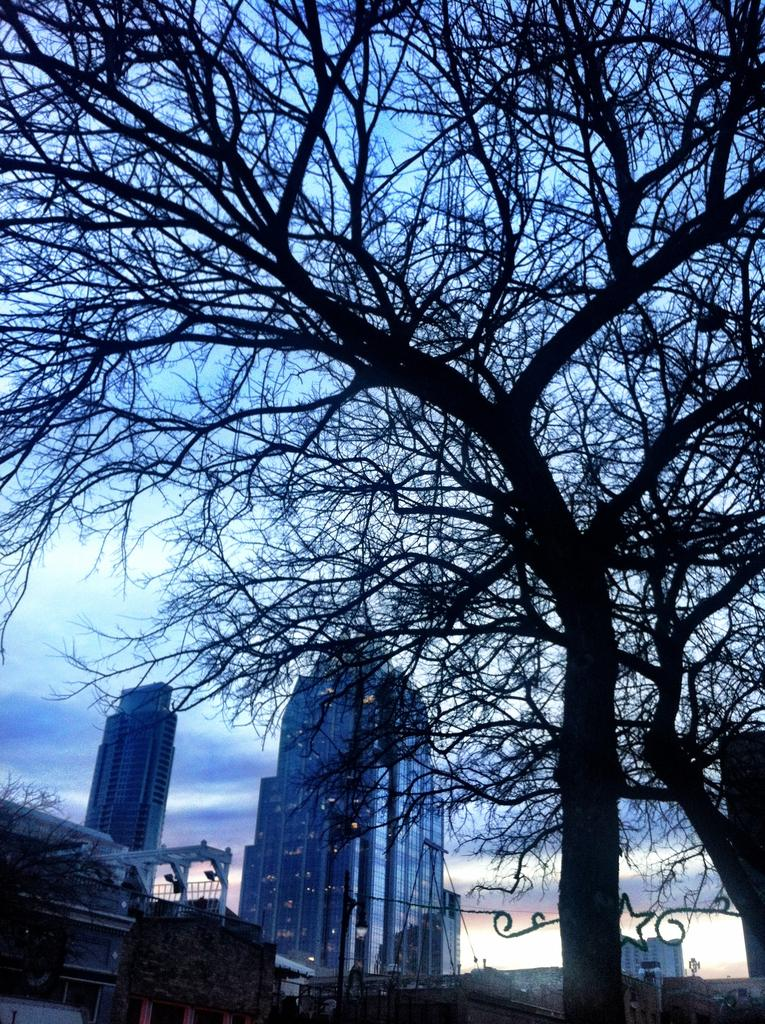What type of structures can be seen in the image? There are buildings in the image. What type of vegetation is present in the image? There are trees and plants in the image. What message is being conveyed by the people saying good-bye in the image? There are no people or any indication of a good-bye message in the image. 